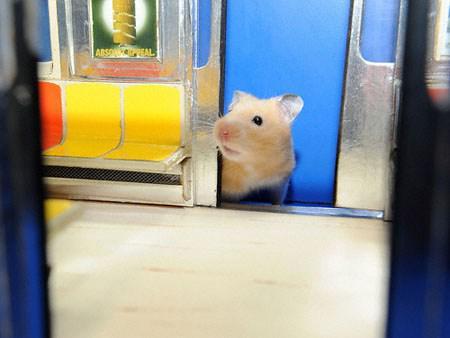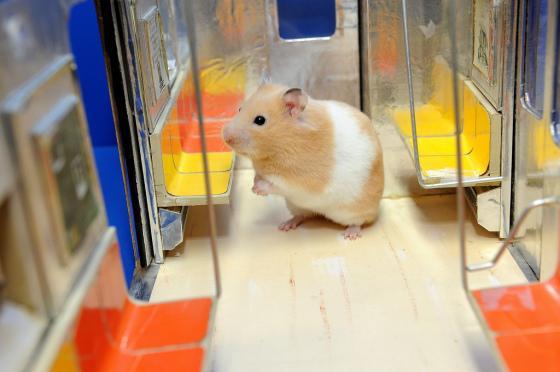The first image is the image on the left, the second image is the image on the right. Analyze the images presented: Is the assertion "1 hamster is in the doorway of a toy train car." valid? Answer yes or no. Yes. The first image is the image on the left, the second image is the image on the right. Examine the images to the left and right. Is the description "There are two mice near yellow and orange seats." accurate? Answer yes or no. Yes. 